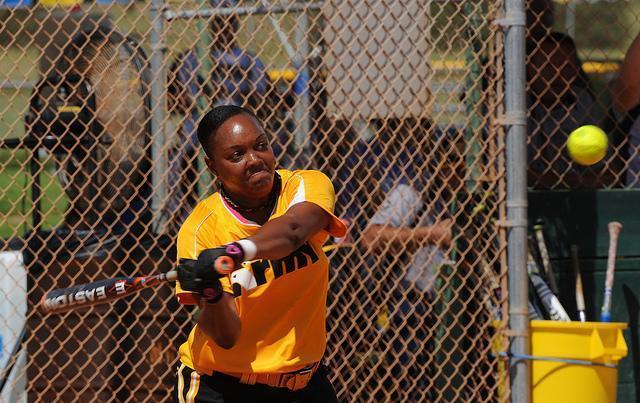How many people are holding bats?
Give a very brief answer. 1. How many people are there?
Give a very brief answer. 2. How many digits is the train number on the right?
Give a very brief answer. 0. 